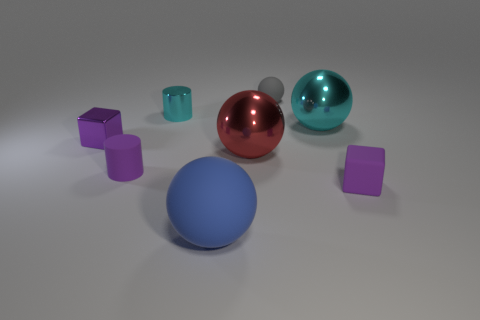Subtract all tiny gray spheres. How many spheres are left? 3 Subtract 1 balls. How many balls are left? 3 Add 1 tiny gray rubber balls. How many objects exist? 9 Subtract all yellow balls. Subtract all yellow blocks. How many balls are left? 4 Subtract all blocks. How many objects are left? 6 Subtract all big red objects. Subtract all big red metal balls. How many objects are left? 6 Add 6 small cyan cylinders. How many small cyan cylinders are left? 7 Add 5 large yellow metal cylinders. How many large yellow metal cylinders exist? 5 Subtract 1 red spheres. How many objects are left? 7 